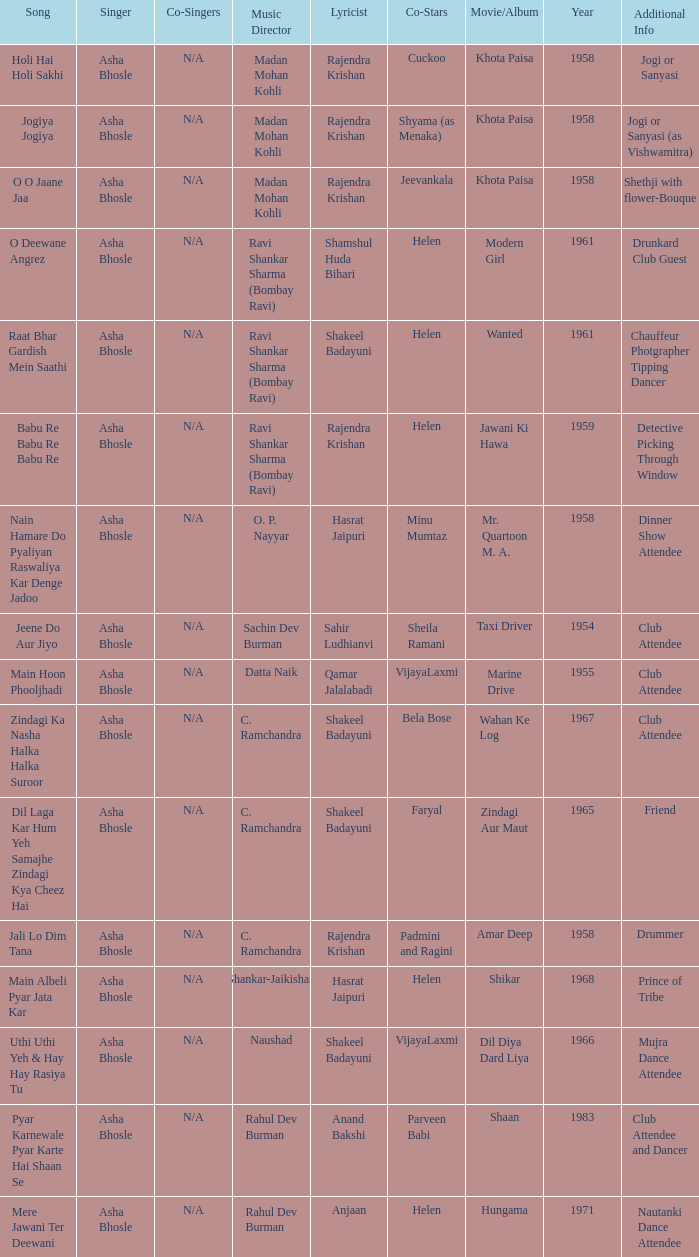What year did Naushad Direct the Music? 1966.0. 